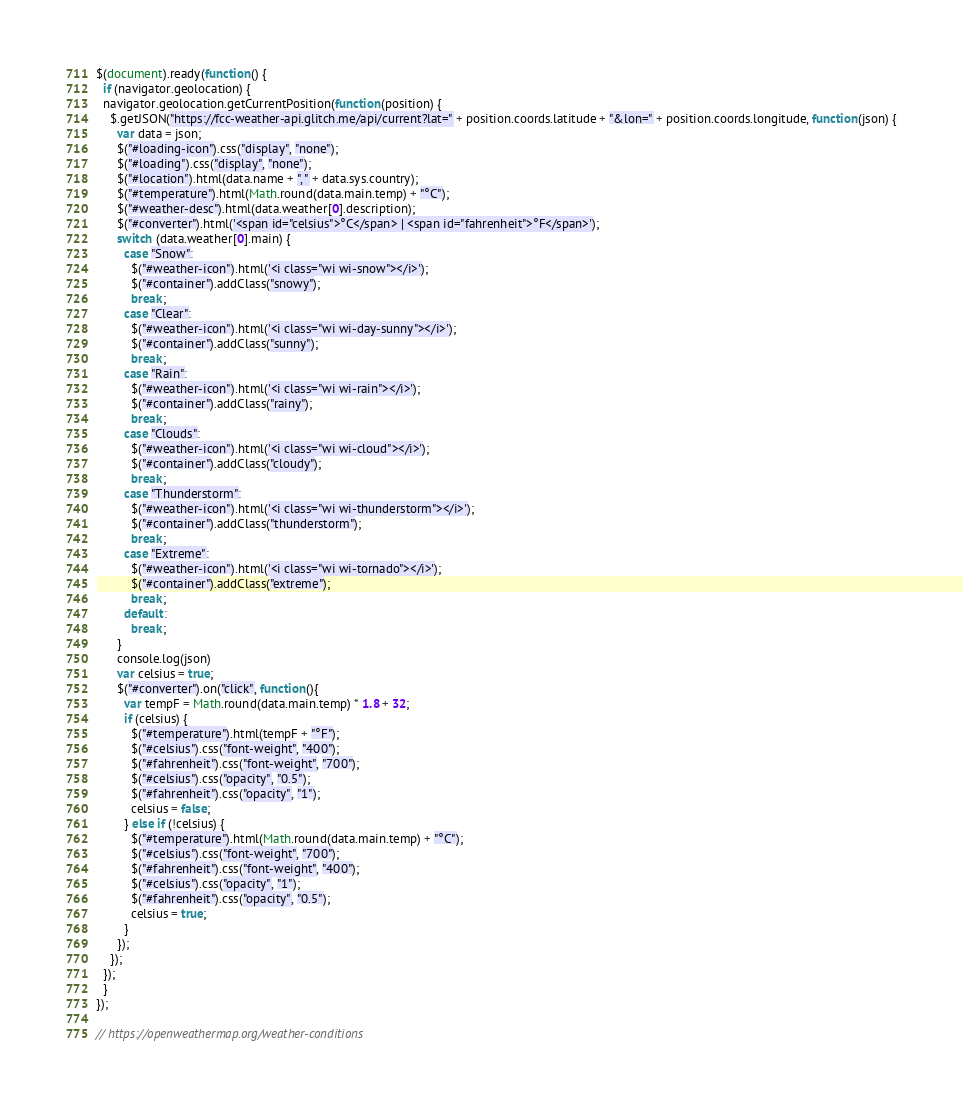Convert code to text. <code><loc_0><loc_0><loc_500><loc_500><_JavaScript_>$(document).ready(function() {
  if (navigator.geolocation) {
  navigator.geolocation.getCurrentPosition(function(position) {
    $.getJSON("https://fcc-weather-api.glitch.me/api/current?lat=" + position.coords.latitude + "&lon=" + position.coords.longitude, function(json) {
      var data = json;
      $("#loading-icon").css("display", "none");
      $("#loading").css("display", "none");
      $("#location").html(data.name + ", " + data.sys.country);
      $("#temperature").html(Math.round(data.main.temp) + "°C");
      $("#weather-desc").html(data.weather[0].description);
      $("#converter").html('<span id="celsius">°C</span> | <span id="fahrenheit">°F</span>');
      switch (data.weather[0].main) {
        case "Snow":
          $("#weather-icon").html('<i class="wi wi-snow"></i>');
          $("#container").addClass("snowy");
          break;
        case "Clear":
          $("#weather-icon").html('<i class="wi wi-day-sunny"></i>');
          $("#container").addClass("sunny");
          break;
        case "Rain":
          $("#weather-icon").html('<i class="wi wi-rain"></i>');
          $("#container").addClass("rainy");
          break;
        case "Clouds":
          $("#weather-icon").html('<i class="wi wi-cloud"></i>');
          $("#container").addClass("cloudy");
          break;
        case "Thunderstorm":
          $("#weather-icon").html('<i class="wi wi-thunderstorm"></i>');
          $("#container").addClass("thunderstorm");
          break;
        case "Extreme":
          $("#weather-icon").html('<i class="wi wi-tornado"></i>');
          $("#container").addClass("extreme");
          break;
        default:
          break;
      }
      console.log(json)
      var celsius = true;
      $("#converter").on("click", function(){
        var tempF = Math.round(data.main.temp) * 1.8 + 32;
        if (celsius) {
          $("#temperature").html(tempF + "°F");
          $("#celsius").css("font-weight", "400");
          $("#fahrenheit").css("font-weight", "700");
          $("#celsius").css("opacity", "0.5");
          $("#fahrenheit").css("opacity", "1");
          celsius = false;
        } else if (!celsius) {
          $("#temperature").html(Math.round(data.main.temp) + "°C");
          $("#celsius").css("font-weight", "700");
          $("#fahrenheit").css("font-weight", "400");
          $("#celsius").css("opacity", "1");
          $("#fahrenheit").css("opacity", "0.5");
          celsius = true;
        }
      });
    });
  });    
  }
});

// https://openweathermap.org/weather-conditions</code> 